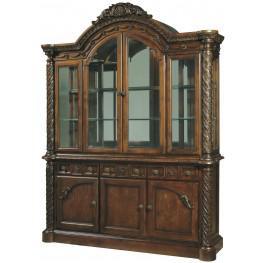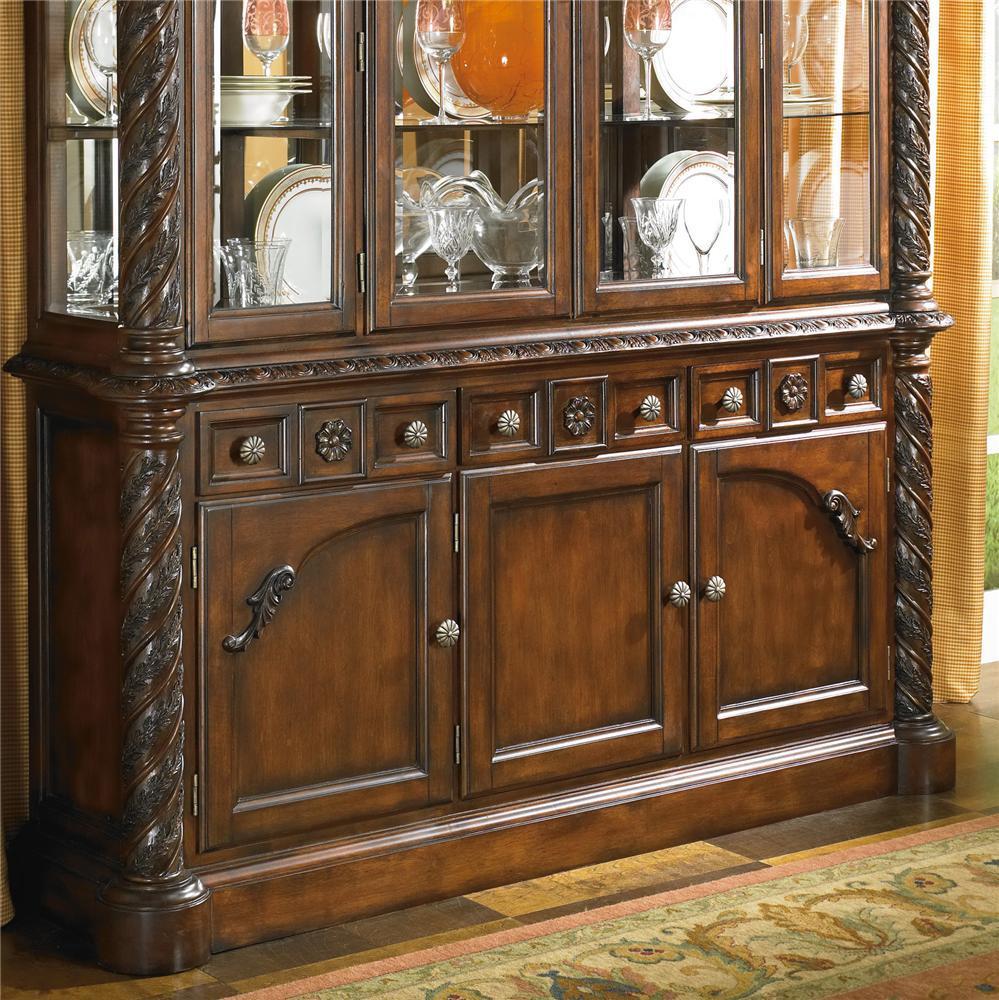The first image is the image on the left, the second image is the image on the right. Assess this claim about the two images: "Two dark hutches have solid wooden doors at the bottom and sit flush to the floor.". Correct or not? Answer yes or no. Yes. 